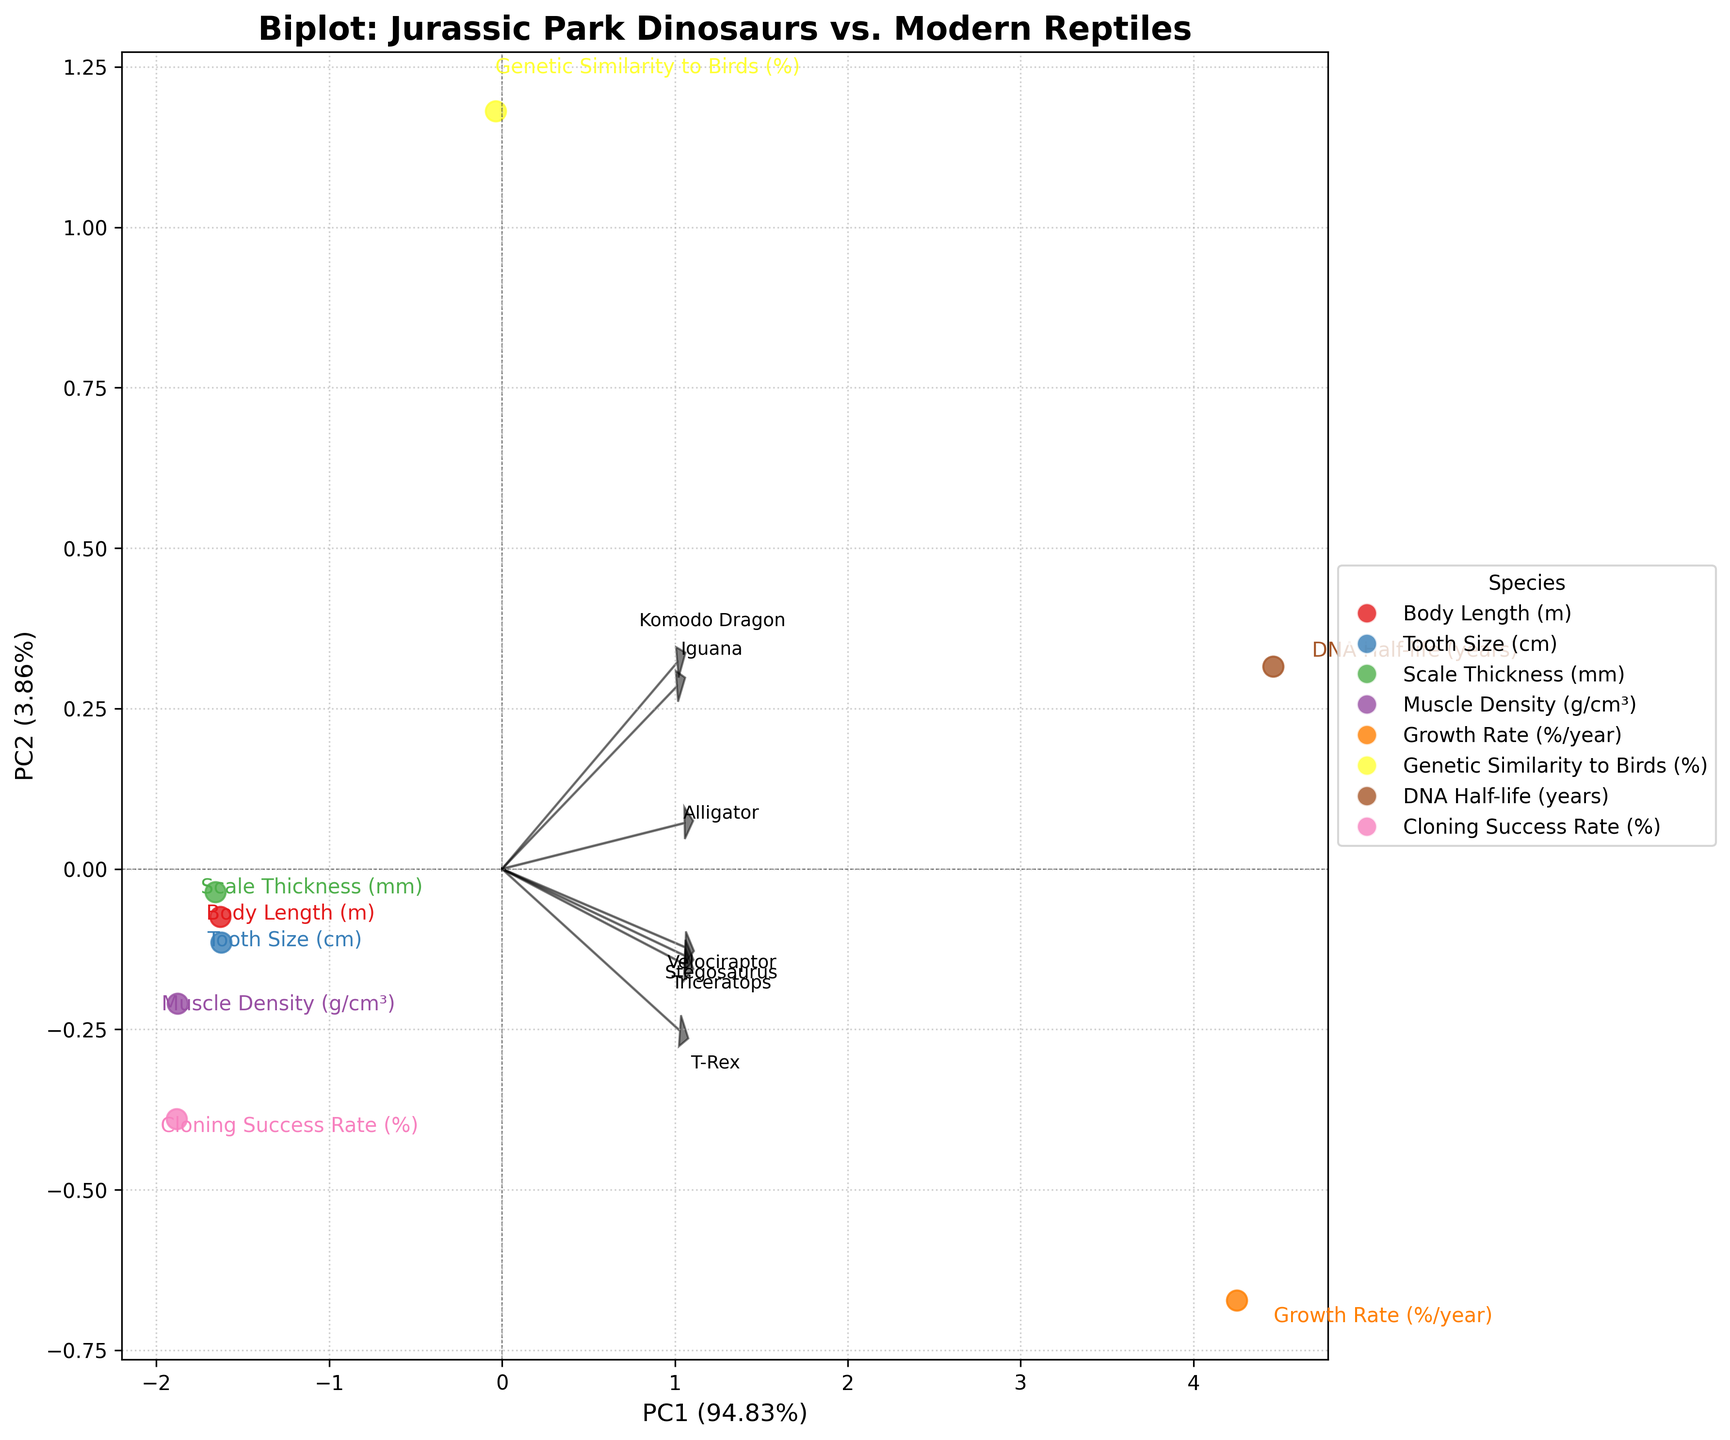What is the title of the biplot? The title is located at the top center of the biplot. It reads "Biplot: Jurassic Park Dinosaurs vs. Modern Reptiles".
Answer: Biplot: Jurassic Park Dinosaurs vs. Modern Reptiles Which dinosaur has the highest value in Cloning Success Rate (%)? Look at the labels corresponding to the dinosaur species on the biplot and check their positions relative to the Cloning Success Rate vector. Velociraptor, labeled "Velociraptor", is the furthest along this vector.
Answer: Velociraptor How many species are plotted in the biplot? Count the number of distinct labeled points plotted on the biplot, each representing a different species. There are seven points corresponding to seven species.
Answer: 7 Which traits are highly correlated with PC1? Observe the direction and length of the vectors. Traits with vectors pointing strongly towards PC1 (horizontal axis) indicate high correlation. The Growth Rate (%/year) vector is the most aligned with the PC1 axis.
Answer: Growth Rate (%/year) Which dinosaur is closest to modern reptiles in terms of Genetic Similarity to Birds (%)? Compare the positions of the dinosaur species with the modern reptiles along the Genetic Similarity to Birds vector. Triceratops, labeled "Triceratops", appears closest to the modern reptiles.
Answer: Triceratops Which species exhibit the largest variance along PC2? Examine the spread of the points along PC2 (vertical axis). T-Rex and Velociraptor are positioned at extreme ends along this axis, indicating large variance.
Answer: T-Rex and Velociraptor Are Tooth Size and Body Length highly correlated in the dinosaurs? Correlation between traits can be inferred by the angle between their vectors. Tooth Size and Body Length vectors are not close to each other, indicating low correlation.
Answer: No Compare the Growth Rate (%/year) of T-Rex and an average modern reptile. Which one grew faster? Check the position of T-Rex along the Growth Rate vector and compare it with the average position of modern reptiles along the same vector. T-Rex is positioned much further along the vector.
Answer: T-Rex Which trait shows the least variation among the species in the biplot? Traits with the shortest vectors indicate the least variation among the species. Muscle Density (g/cm³) has the shortest vector.
Answer: Muscle Density (g/cm³) What percentage of the total variance is explained by PC1 and PC2 combined? Add the percentages labeled on the PC1 and PC2 axes. Assuming PC1 is 68% and PC2 is 18%, the total is 68% + 18%.
Answer: 86% 